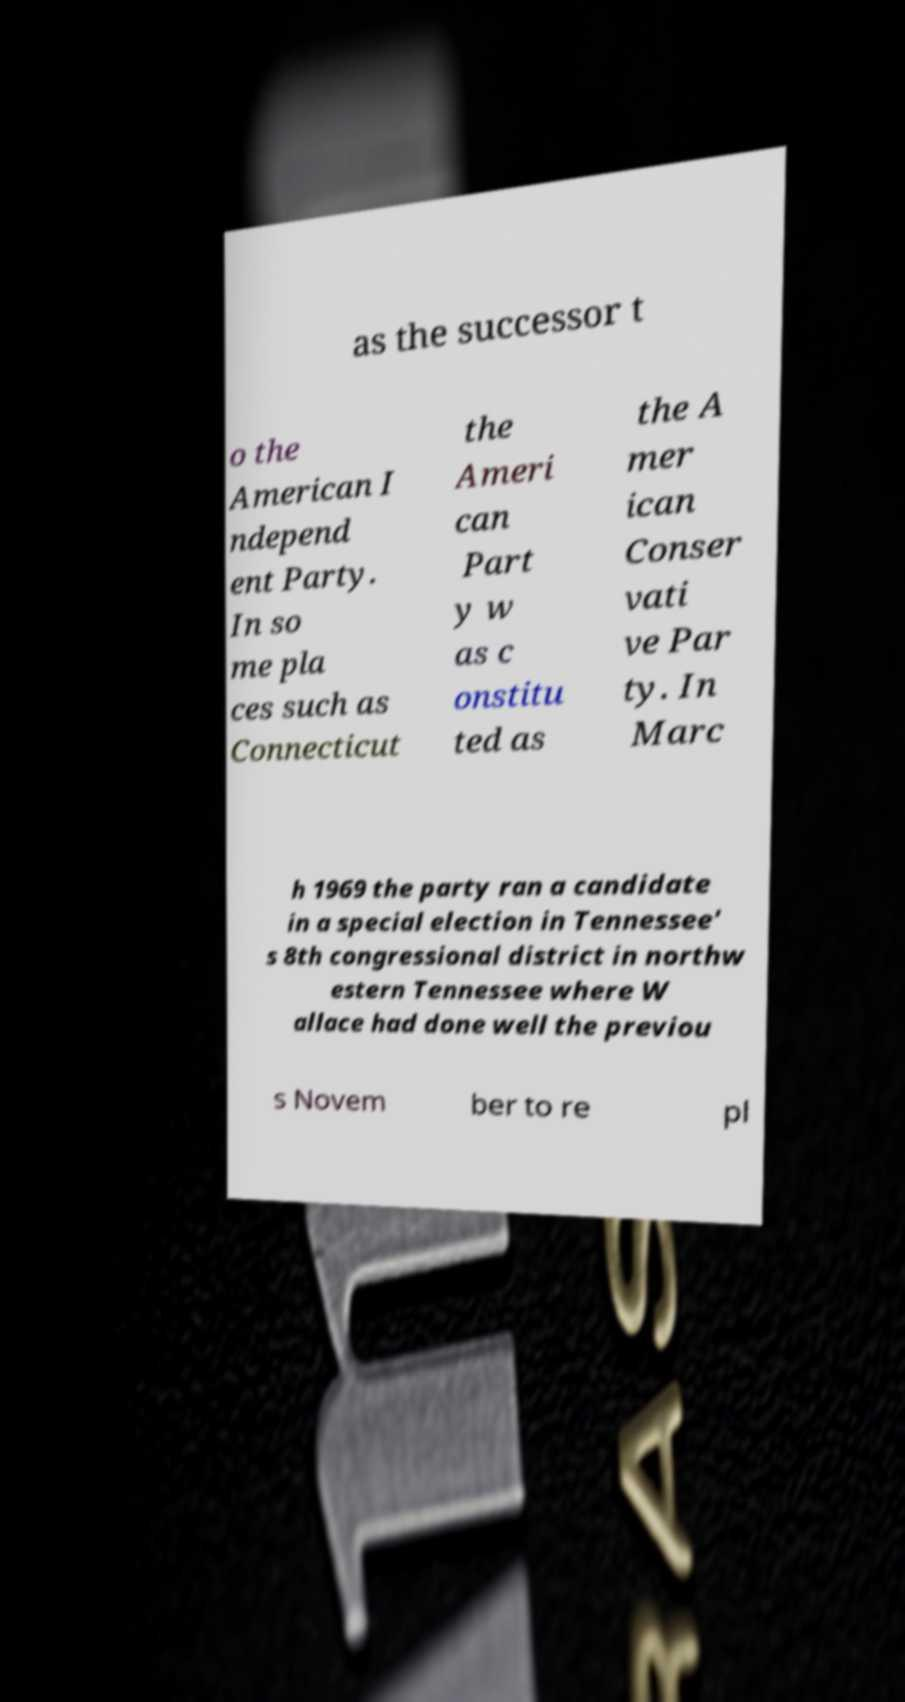Could you extract and type out the text from this image? as the successor t o the American I ndepend ent Party. In so me pla ces such as Connecticut the Ameri can Part y w as c onstitu ted as the A mer ican Conser vati ve Par ty. In Marc h 1969 the party ran a candidate in a special election in Tennessee' s 8th congressional district in northw estern Tennessee where W allace had done well the previou s Novem ber to re pl 